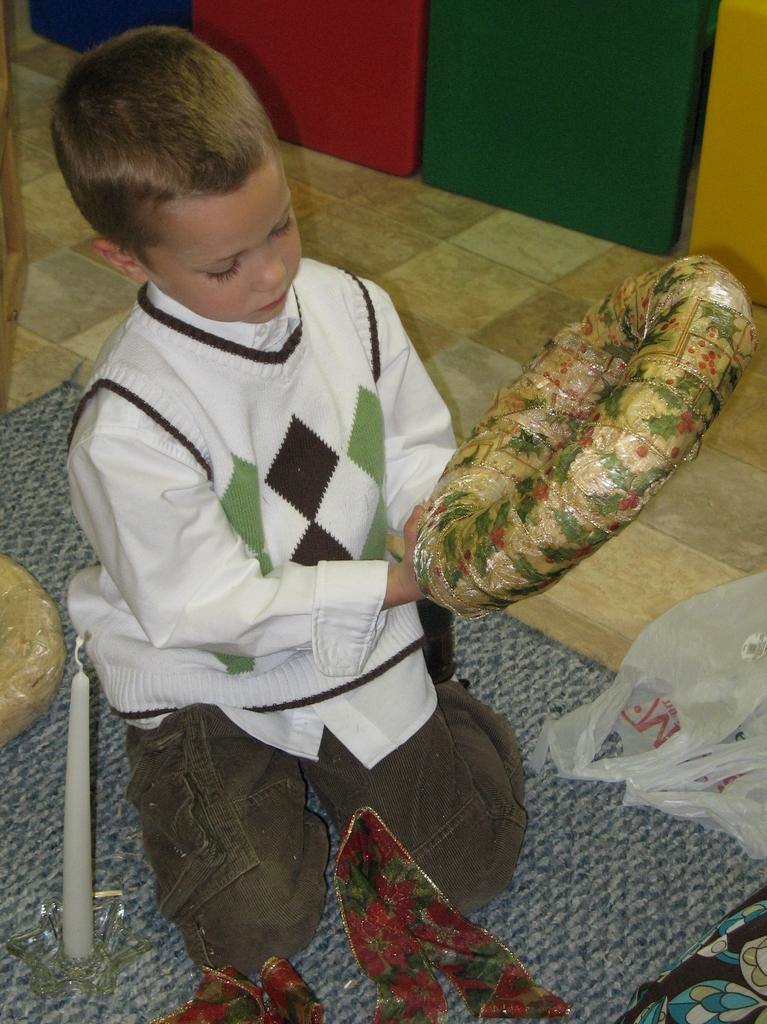What is the main subject in the foreground of the image? There is a boy in the foreground of the image. What is the boy holding in his hand? The boy is holding an object in his hand. What can be seen in the background of the image? There are boxes in the background of the image. Can you describe the setting of the image? The image may have been taken in a hall. What type of beef is the boy eating in the image? There is no beef present in the image; the boy is holding an object in his hand. Can you tell me how many dinosaurs are visible in the image? There are no dinosaurs present in the image; the main subject is a boy in a possible hall setting. 